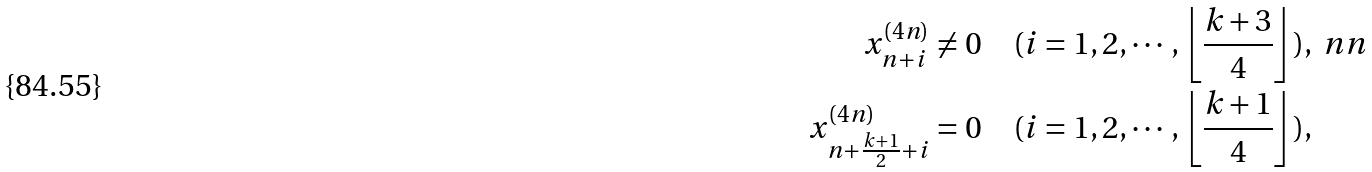<formula> <loc_0><loc_0><loc_500><loc_500>x _ { n + i } ^ { ( 4 n ) } & \neq 0 \quad ( i = 1 , 2 , \cdots , \left \lfloor \frac { k + 3 } { 4 } \right \rfloor ) , \ n n \\ x _ { n + \frac { k + 1 } { 2 } + i } ^ { ( 4 n ) } & = 0 \quad ( i = 1 , 2 , \cdots , \left \lfloor \frac { k + 1 } { 4 } \right \rfloor ) ,</formula> 